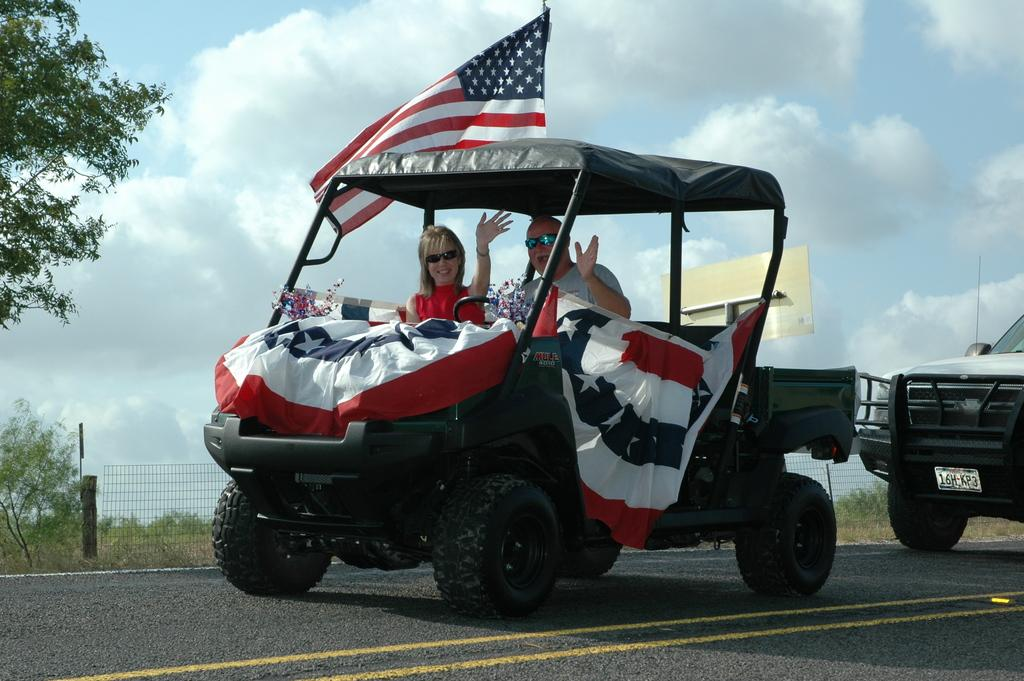Who is present in the image? There is a man and a woman in the image. What are they doing in the image? They are riding in a vehicle. What can be seen on the vehicle they are riding? There are flags on the vehicle. Can you describe the surrounding environment in the image? There is another vehicle behind them, trees, a fence, and the sky with clouds in the background of the image. What type of camera can be seen in the image? There is no camera present in the image. Can you describe the sail on the vehicle in the image? There is no sail on the vehicle in the image. 